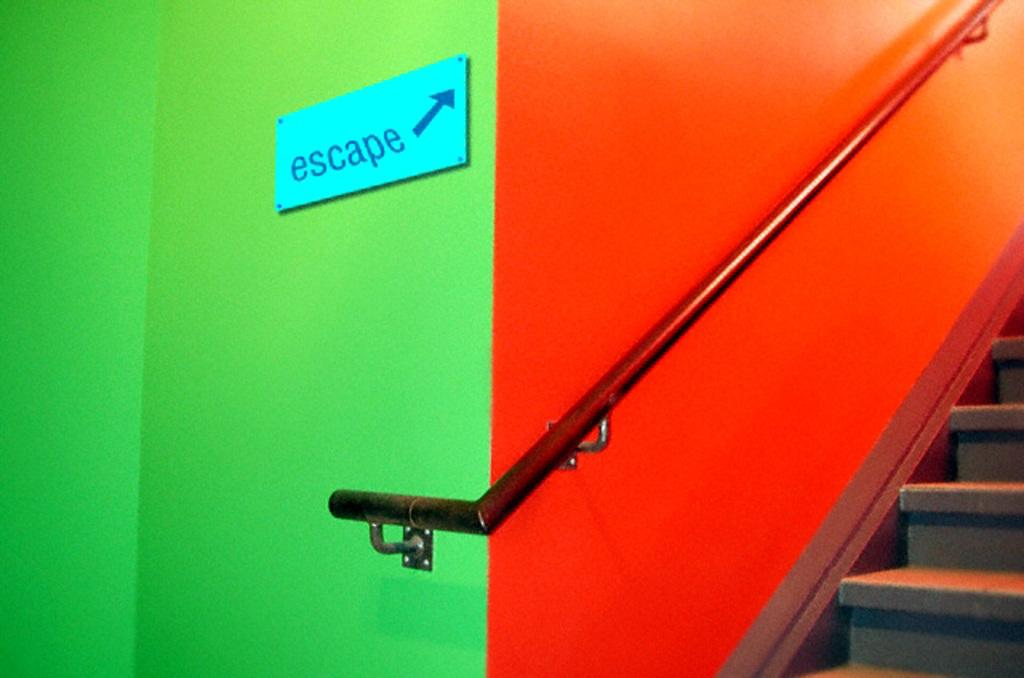What color is the wall on the left side of the image? There is a green color wall in the image. What is attached to the green wall? There is an escape board attached to the green wall. What color is the wall on the right side of the image? There is an orange wall in the image. What can be seen beside the orange wall? There are stairs leading upwards beside the orange wall. What type of wrench is being used to adjust the scale in the image? There is no wrench or scale present in the image. What kind of art can be seen hanging on the orange wall? There is no art visible on the orange wall in the image. 